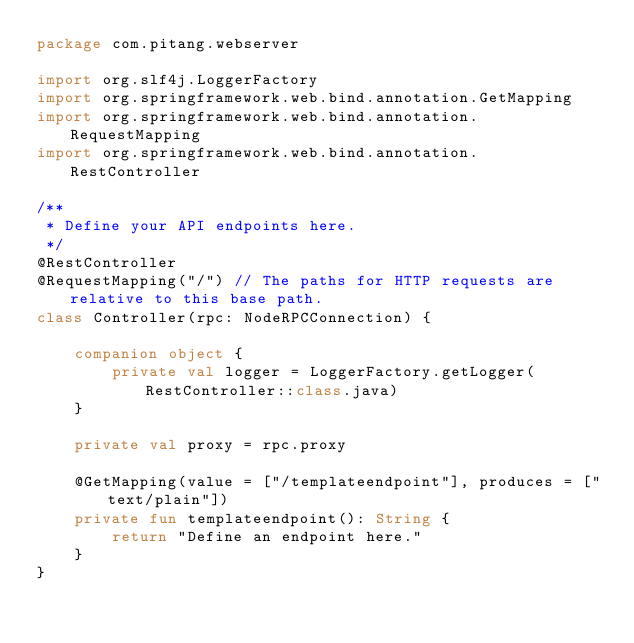Convert code to text. <code><loc_0><loc_0><loc_500><loc_500><_Kotlin_>package com.pitang.webserver

import org.slf4j.LoggerFactory
import org.springframework.web.bind.annotation.GetMapping
import org.springframework.web.bind.annotation.RequestMapping
import org.springframework.web.bind.annotation.RestController

/**
 * Define your API endpoints here.
 */
@RestController
@RequestMapping("/") // The paths for HTTP requests are relative to this base path.
class Controller(rpc: NodeRPCConnection) {

    companion object {
        private val logger = LoggerFactory.getLogger(RestController::class.java)
    }

    private val proxy = rpc.proxy

    @GetMapping(value = ["/templateendpoint"], produces = ["text/plain"])
    private fun templateendpoint(): String {
        return "Define an endpoint here."
    }
}</code> 